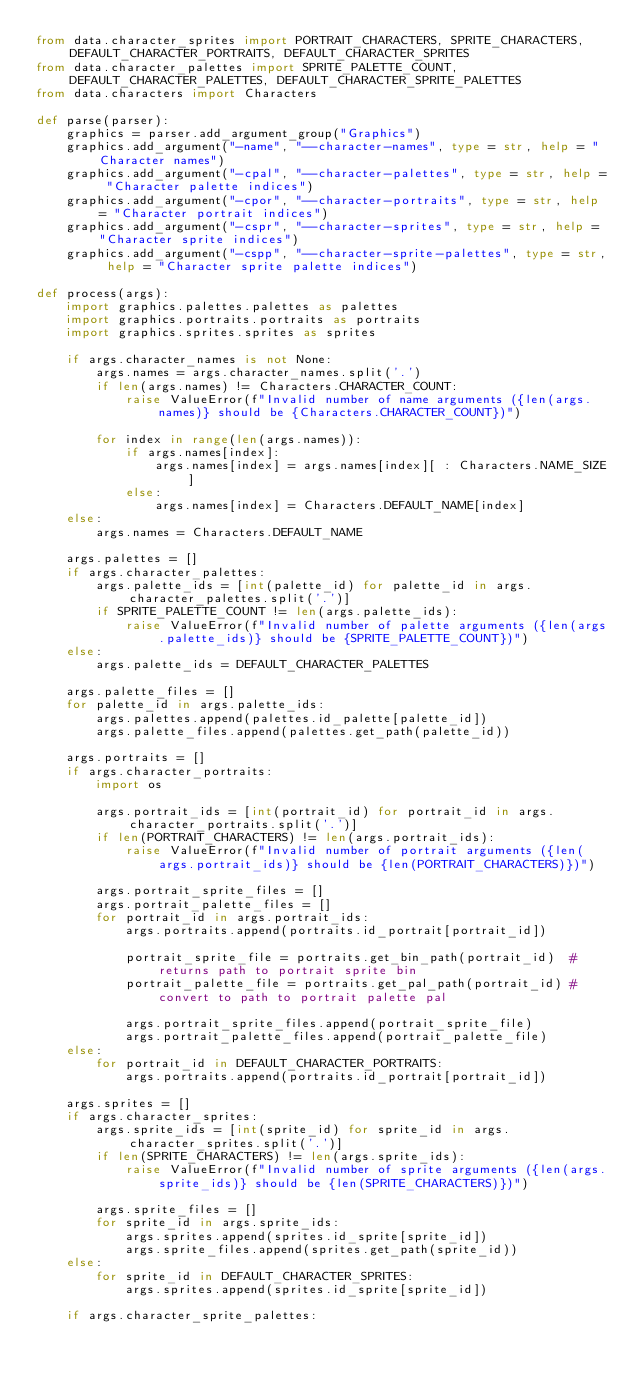<code> <loc_0><loc_0><loc_500><loc_500><_Python_>from data.character_sprites import PORTRAIT_CHARACTERS, SPRITE_CHARACTERS, DEFAULT_CHARACTER_PORTRAITS, DEFAULT_CHARACTER_SPRITES
from data.character_palettes import SPRITE_PALETTE_COUNT, DEFAULT_CHARACTER_PALETTES, DEFAULT_CHARACTER_SPRITE_PALETTES
from data.characters import Characters

def parse(parser):
    graphics = parser.add_argument_group("Graphics")
    graphics.add_argument("-name", "--character-names", type = str, help = "Character names")
    graphics.add_argument("-cpal", "--character-palettes", type = str, help = "Character palette indices")
    graphics.add_argument("-cpor", "--character-portraits", type = str, help = "Character portrait indices")
    graphics.add_argument("-cspr", "--character-sprites", type = str, help = "Character sprite indices")
    graphics.add_argument("-cspp", "--character-sprite-palettes", type = str, help = "Character sprite palette indices")

def process(args):
    import graphics.palettes.palettes as palettes
    import graphics.portraits.portraits as portraits
    import graphics.sprites.sprites as sprites

    if args.character_names is not None:
        args.names = args.character_names.split('.')
        if len(args.names) != Characters.CHARACTER_COUNT:
            raise ValueError(f"Invalid number of name arguments ({len(args.names)} should be {Characters.CHARACTER_COUNT})")

        for index in range(len(args.names)):
            if args.names[index]:
                args.names[index] = args.names[index][ : Characters.NAME_SIZE]
            else:
                args.names[index] = Characters.DEFAULT_NAME[index]
    else:
        args.names = Characters.DEFAULT_NAME

    args.palettes = []
    if args.character_palettes:
        args.palette_ids = [int(palette_id) for palette_id in args.character_palettes.split('.')]
        if SPRITE_PALETTE_COUNT != len(args.palette_ids):
            raise ValueError(f"Invalid number of palette arguments ({len(args.palette_ids)} should be {SPRITE_PALETTE_COUNT})")
    else:
        args.palette_ids = DEFAULT_CHARACTER_PALETTES

    args.palette_files = []
    for palette_id in args.palette_ids:
        args.palettes.append(palettes.id_palette[palette_id])
        args.palette_files.append(palettes.get_path(palette_id))

    args.portraits = []
    if args.character_portraits:
        import os

        args.portrait_ids = [int(portrait_id) for portrait_id in args.character_portraits.split('.')]
        if len(PORTRAIT_CHARACTERS) != len(args.portrait_ids):
            raise ValueError(f"Invalid number of portrait arguments ({len(args.portrait_ids)} should be {len(PORTRAIT_CHARACTERS)})")

        args.portrait_sprite_files = []
        args.portrait_palette_files = []
        for portrait_id in args.portrait_ids:
            args.portraits.append(portraits.id_portrait[portrait_id])

            portrait_sprite_file = portraits.get_bin_path(portrait_id)  # returns path to portrait sprite bin
            portrait_palette_file = portraits.get_pal_path(portrait_id) # convert to path to portrait palette pal

            args.portrait_sprite_files.append(portrait_sprite_file)
            args.portrait_palette_files.append(portrait_palette_file)
    else:
        for portrait_id in DEFAULT_CHARACTER_PORTRAITS:
            args.portraits.append(portraits.id_portrait[portrait_id])

    args.sprites = []
    if args.character_sprites:
        args.sprite_ids = [int(sprite_id) for sprite_id in args.character_sprites.split('.')]
        if len(SPRITE_CHARACTERS) != len(args.sprite_ids):
            raise ValueError(f"Invalid number of sprite arguments ({len(args.sprite_ids)} should be {len(SPRITE_CHARACTERS)})")

        args.sprite_files = []
        for sprite_id in args.sprite_ids:
            args.sprites.append(sprites.id_sprite[sprite_id])
            args.sprite_files.append(sprites.get_path(sprite_id))
    else:
        for sprite_id in DEFAULT_CHARACTER_SPRITES:
            args.sprites.append(sprites.id_sprite[sprite_id])

    if args.character_sprite_palettes:</code> 